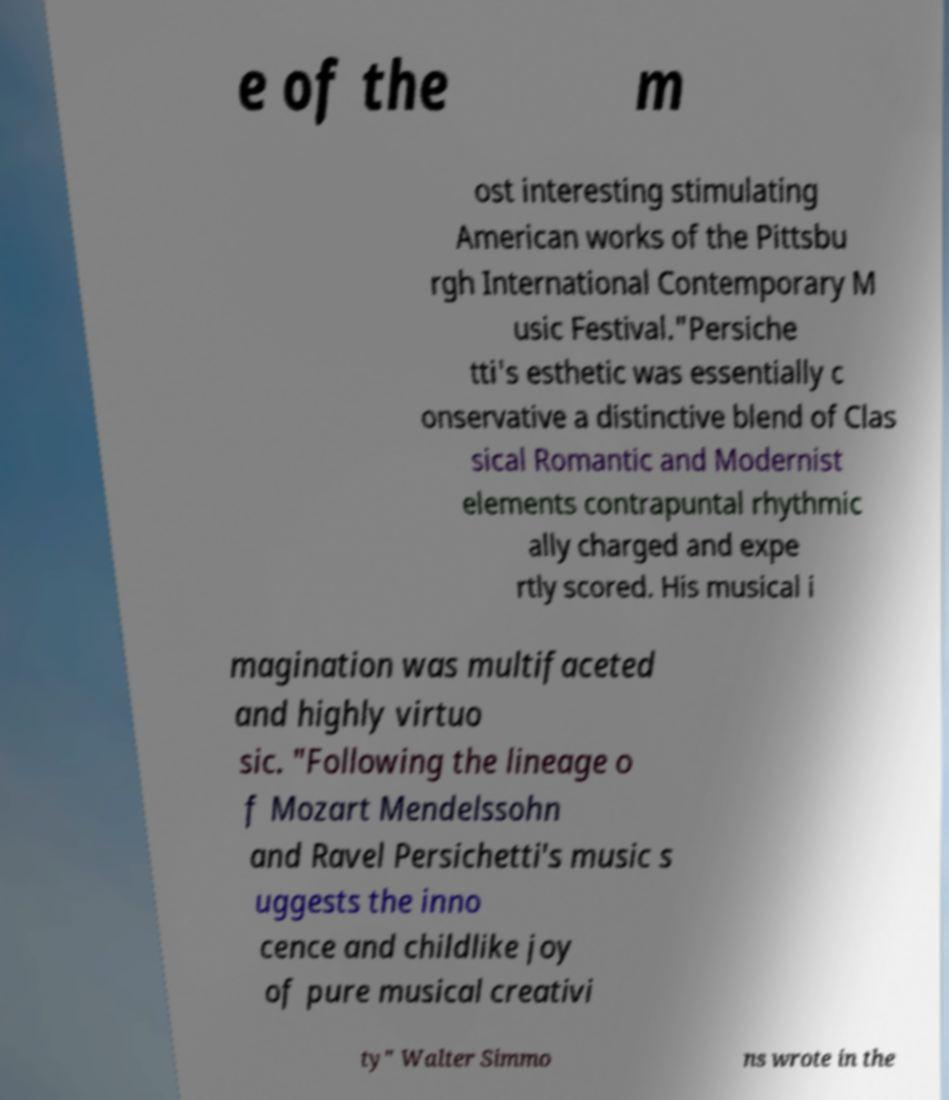There's text embedded in this image that I need extracted. Can you transcribe it verbatim? e of the m ost interesting stimulating American works of the Pittsbu rgh International Contemporary M usic Festival."Persiche tti's esthetic was essentially c onservative a distinctive blend of Clas sical Romantic and Modernist elements contrapuntal rhythmic ally charged and expe rtly scored. His musical i magination was multifaceted and highly virtuo sic. "Following the lineage o f Mozart Mendelssohn and Ravel Persichetti's music s uggests the inno cence and childlike joy of pure musical creativi ty" Walter Simmo ns wrote in the 